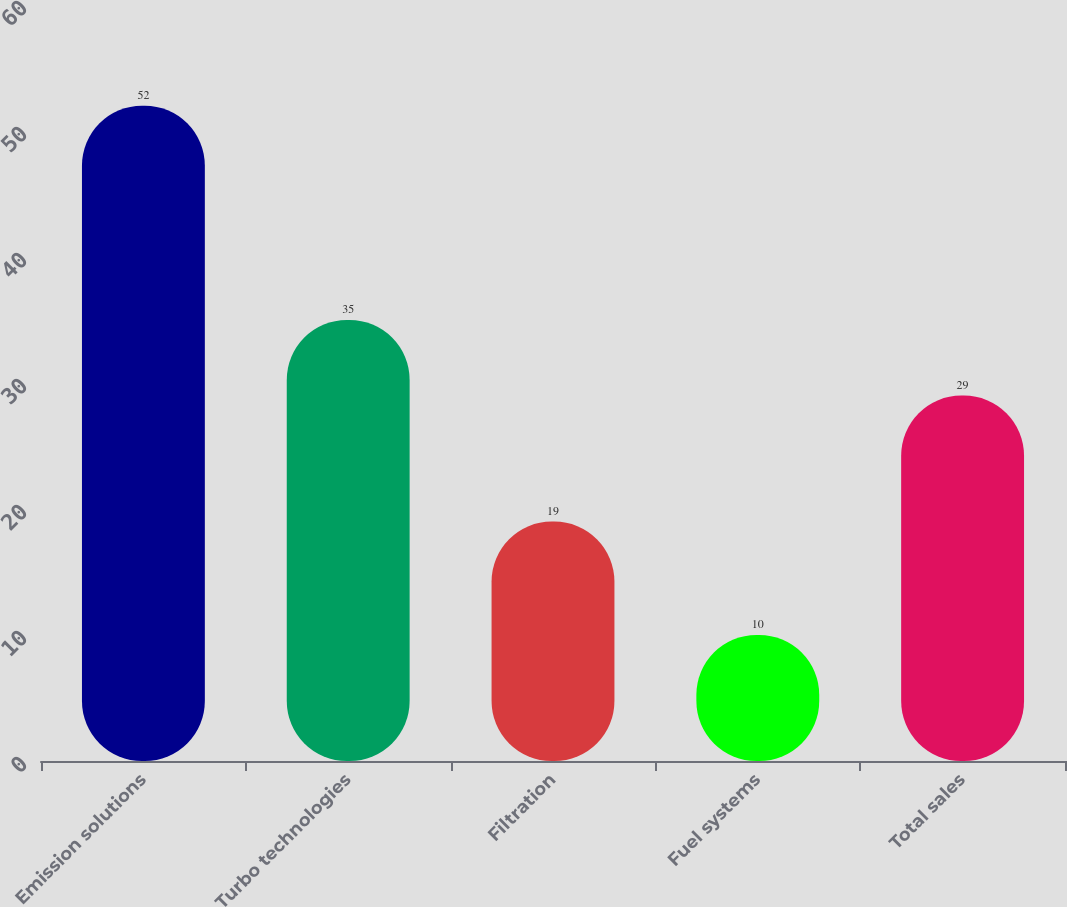Convert chart. <chart><loc_0><loc_0><loc_500><loc_500><bar_chart><fcel>Emission solutions<fcel>Turbo technologies<fcel>Filtration<fcel>Fuel systems<fcel>Total sales<nl><fcel>52<fcel>35<fcel>19<fcel>10<fcel>29<nl></chart> 